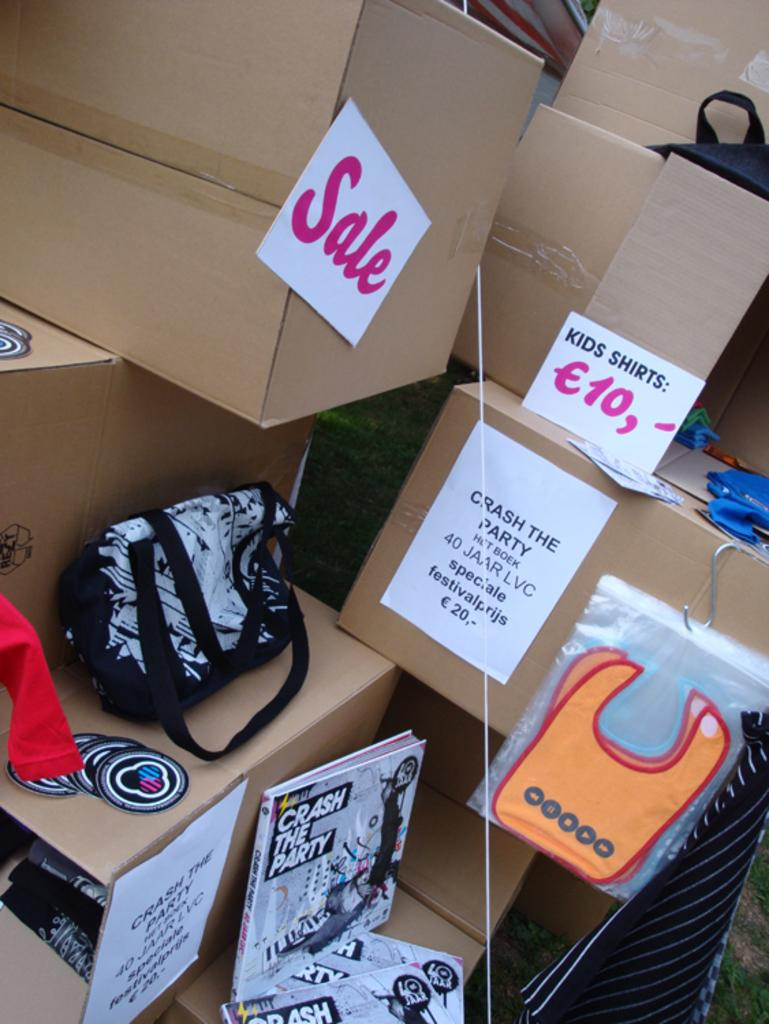Provide a one-sentence caption for the provided image. Bunch of boxes with a Sales box right next to a Kids Shirt box. 